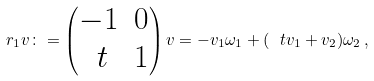<formula> <loc_0><loc_0><loc_500><loc_500>r _ { 1 } v \colon = \begin{pmatrix} - 1 & 0 \\ \ t & 1 \end{pmatrix} v = - v _ { 1 } \omega _ { 1 } + ( \ t v _ { 1 } + v _ { 2 } ) \omega _ { 2 } \, ,</formula> 